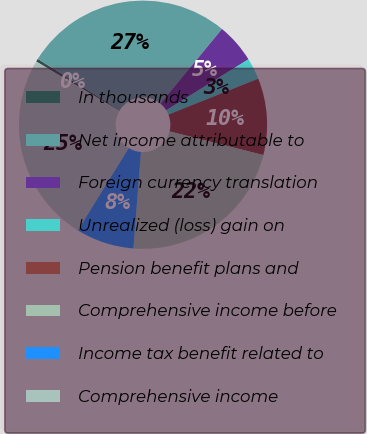Convert chart to OTSL. <chart><loc_0><loc_0><loc_500><loc_500><pie_chart><fcel>In thousands<fcel>Net income attributable to<fcel>Foreign currency translation<fcel>Unrealized (loss) gain on<fcel>Pension benefit plans and<fcel>Comprehensive income before<fcel>Income tax benefit related to<fcel>Comprehensive income<nl><fcel>0.4%<fcel>27.08%<fcel>5.19%<fcel>2.79%<fcel>9.98%<fcel>22.3%<fcel>7.58%<fcel>24.69%<nl></chart> 